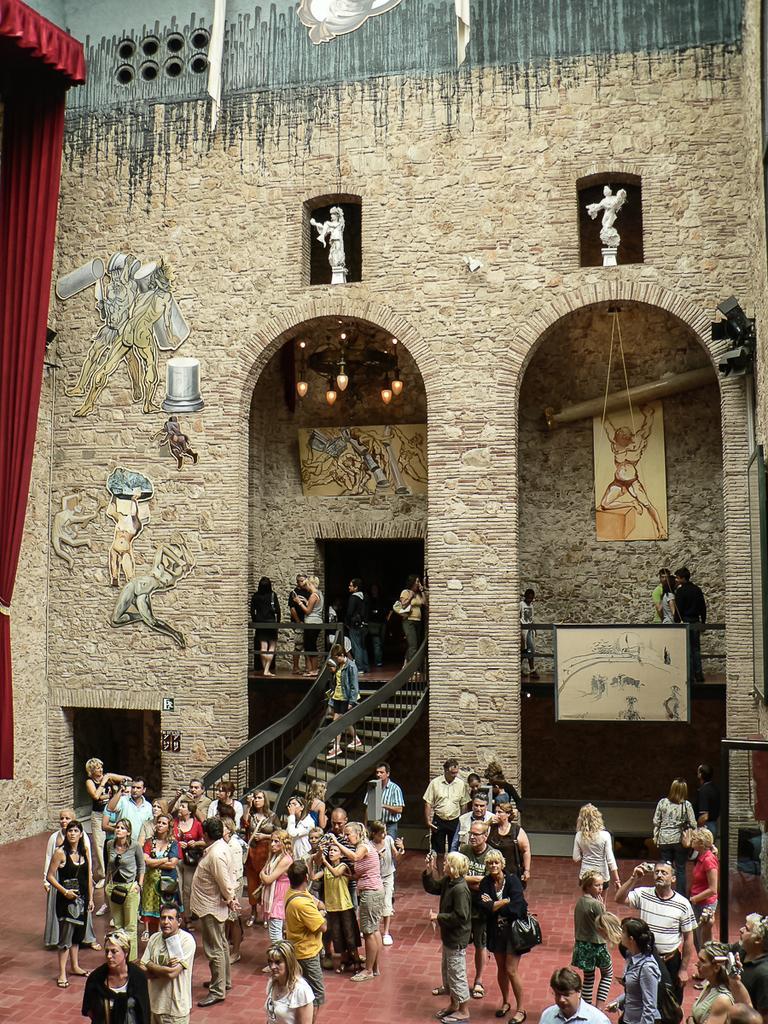Can you describe this image briefly? In this image I can see number of people are standing. I can also see stairs, few boards, few sculptures, red colour curtain and I can also see graffiti on this wall. 